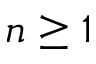<formula> <loc_0><loc_0><loc_500><loc_500>n \geq 1</formula> 